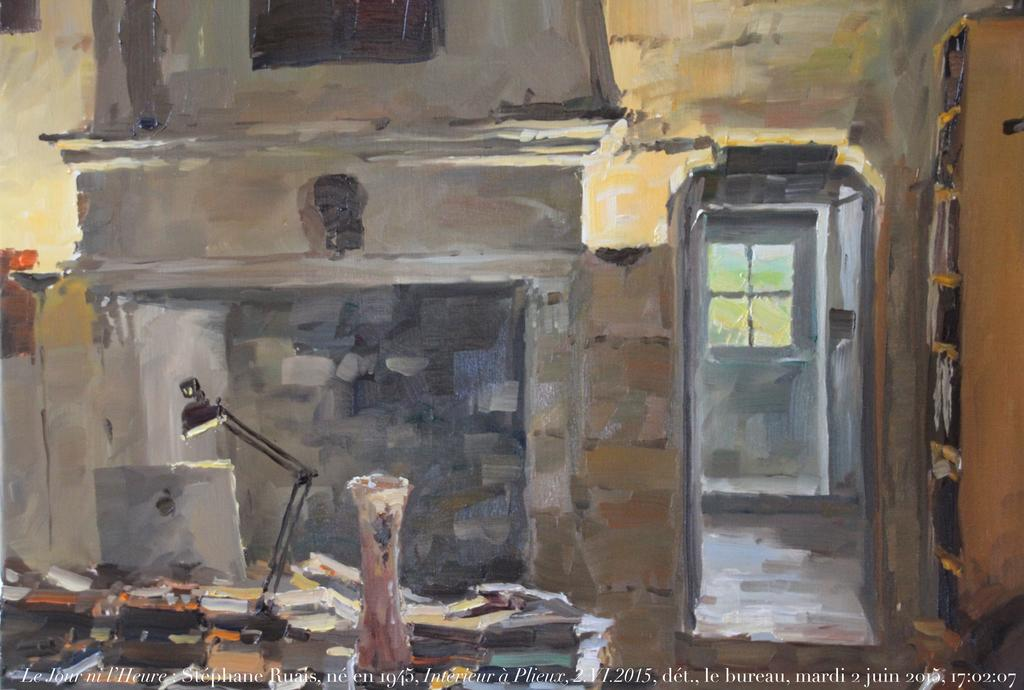<image>
Describe the image concisely. The painting was completed by Stephane Ruais in 2015. 